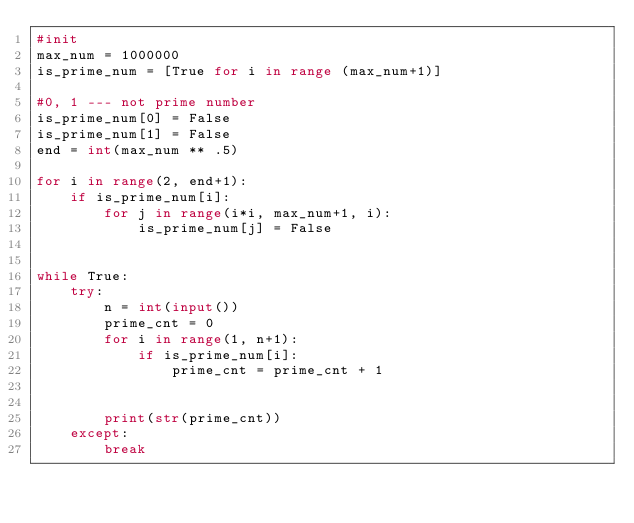Convert code to text. <code><loc_0><loc_0><loc_500><loc_500><_Python_>#init
max_num = 1000000
is_prime_num = [True for i in range (max_num+1)]

#0, 1 --- not prime number
is_prime_num[0] = False
is_prime_num[1] = False
end = int(max_num ** .5)

for i in range(2, end+1):
    if is_prime_num[i]:
        for j in range(i*i, max_num+1, i):
            is_prime_num[j] = False


while True:
    try:
        n = int(input())
        prime_cnt = 0
        for i in range(1, n+1):
            if is_prime_num[i]:
                prime_cnt = prime_cnt + 1
                   
   
        print(str(prime_cnt))
    except:
        break
    </code> 